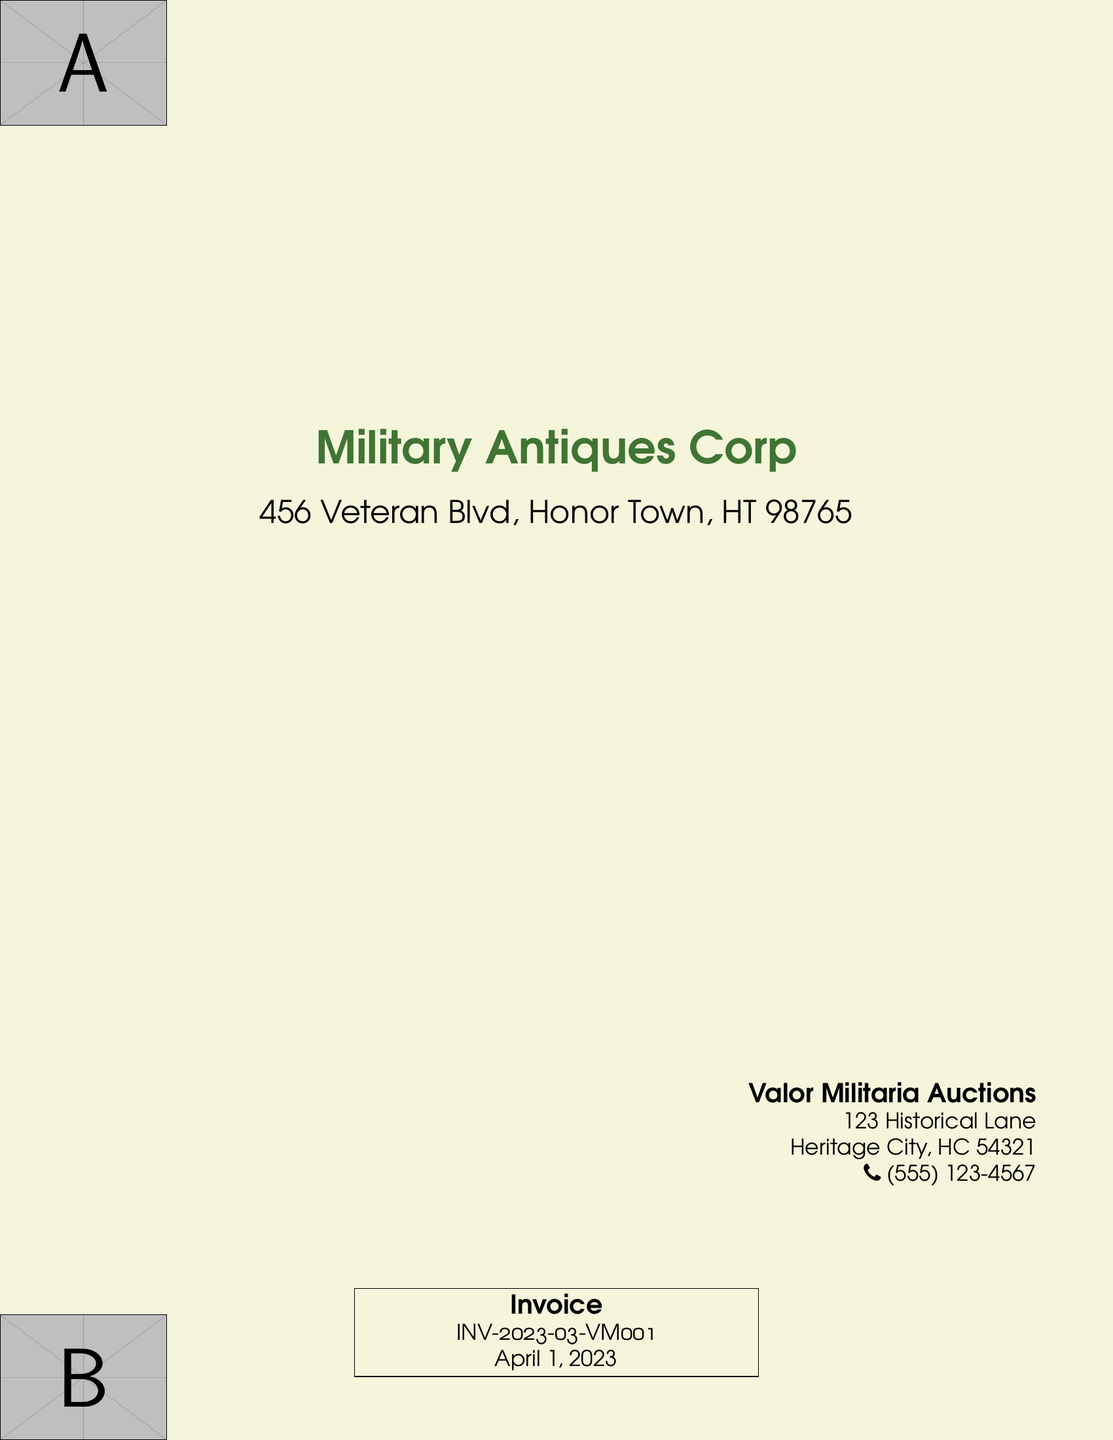What is the name of the company on the envelope? The company's name is prominently displayed at the top of the envelope.
Answer: Military Antiques Corp What is the address of the company? The address is printed below the company's name on the envelope.
Answer: 456 Veteran Blvd, Honor Town, HT 98765 Who is the recipient of the invoice? The recipient's details are located on the right side of the envelope, indicating to whom the invoice is addressed.
Answer: Valor Militaria Auctions What is the phone number listed for the recipient? The phone number is included in the recipient's address section, providing contact information for Valor Militaria Auctions.
Answer: (555) 123-4567 What is the invoice number? The invoice number is clearly stated on the invoice section of the envelope, allowing for easy tracking.
Answer: INV-2023-03-VM001 On what date was the invoice issued? The invoice issue date is noted in the invoice section, providing context for the billing period.
Answer: April 1, 2023 What is the visual theme color of the envelope? The envelope incorporates a specific color that is visually consistent throughout its design.
Answer: Military green How many wall papers are used in the design? The document mentions corner wall papers that enhance aesthetic appeal, specifically how many are utilized in the layout.
Answer: Two What is the purpose of the document? The central element of the envelope indicates the primary use or intent of the document, which is a standard commercial function.
Answer: Invoice 